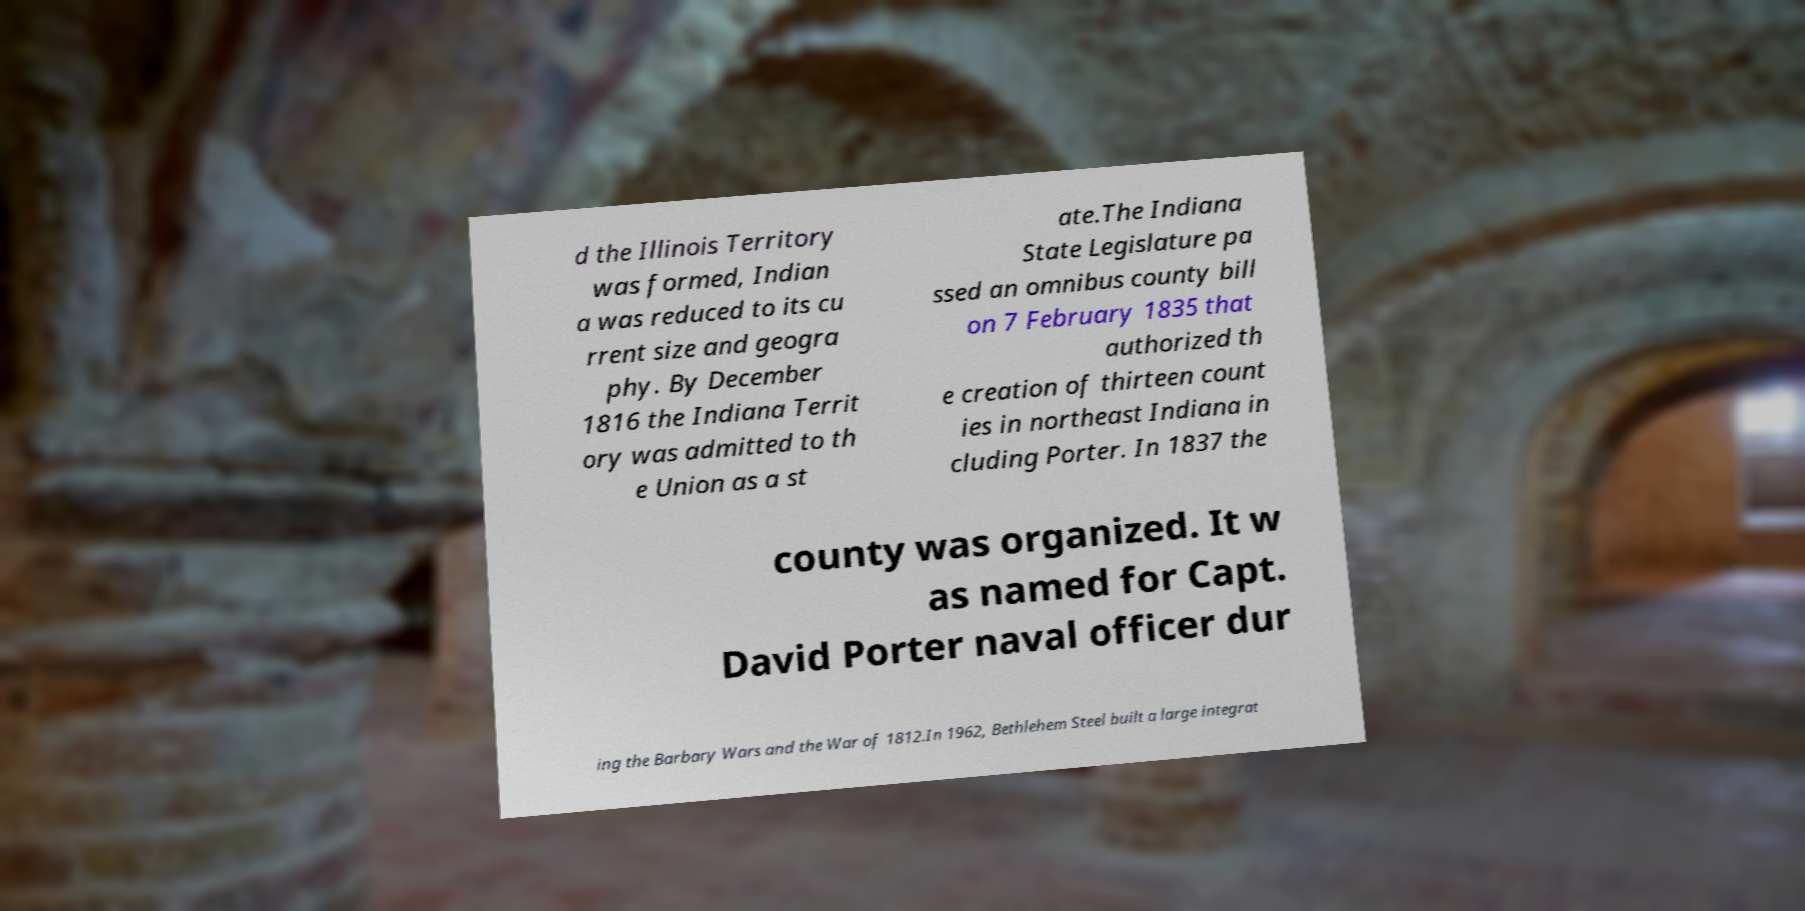Could you extract and type out the text from this image? d the Illinois Territory was formed, Indian a was reduced to its cu rrent size and geogra phy. By December 1816 the Indiana Territ ory was admitted to th e Union as a st ate.The Indiana State Legislature pa ssed an omnibus county bill on 7 February 1835 that authorized th e creation of thirteen count ies in northeast Indiana in cluding Porter. In 1837 the county was organized. It w as named for Capt. David Porter naval officer dur ing the Barbary Wars and the War of 1812.In 1962, Bethlehem Steel built a large integrat 